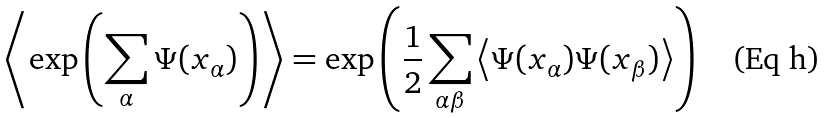<formula> <loc_0><loc_0><loc_500><loc_500>\left < \exp \left ( \sum _ { \alpha } \Psi ( x _ { \alpha } ) \right ) \right > = \exp \left ( \frac { 1 } { 2 } \sum _ { \alpha \beta } \left < \Psi ( x _ { \alpha } ) \Psi ( x _ { \beta } ) \right > \right )</formula> 